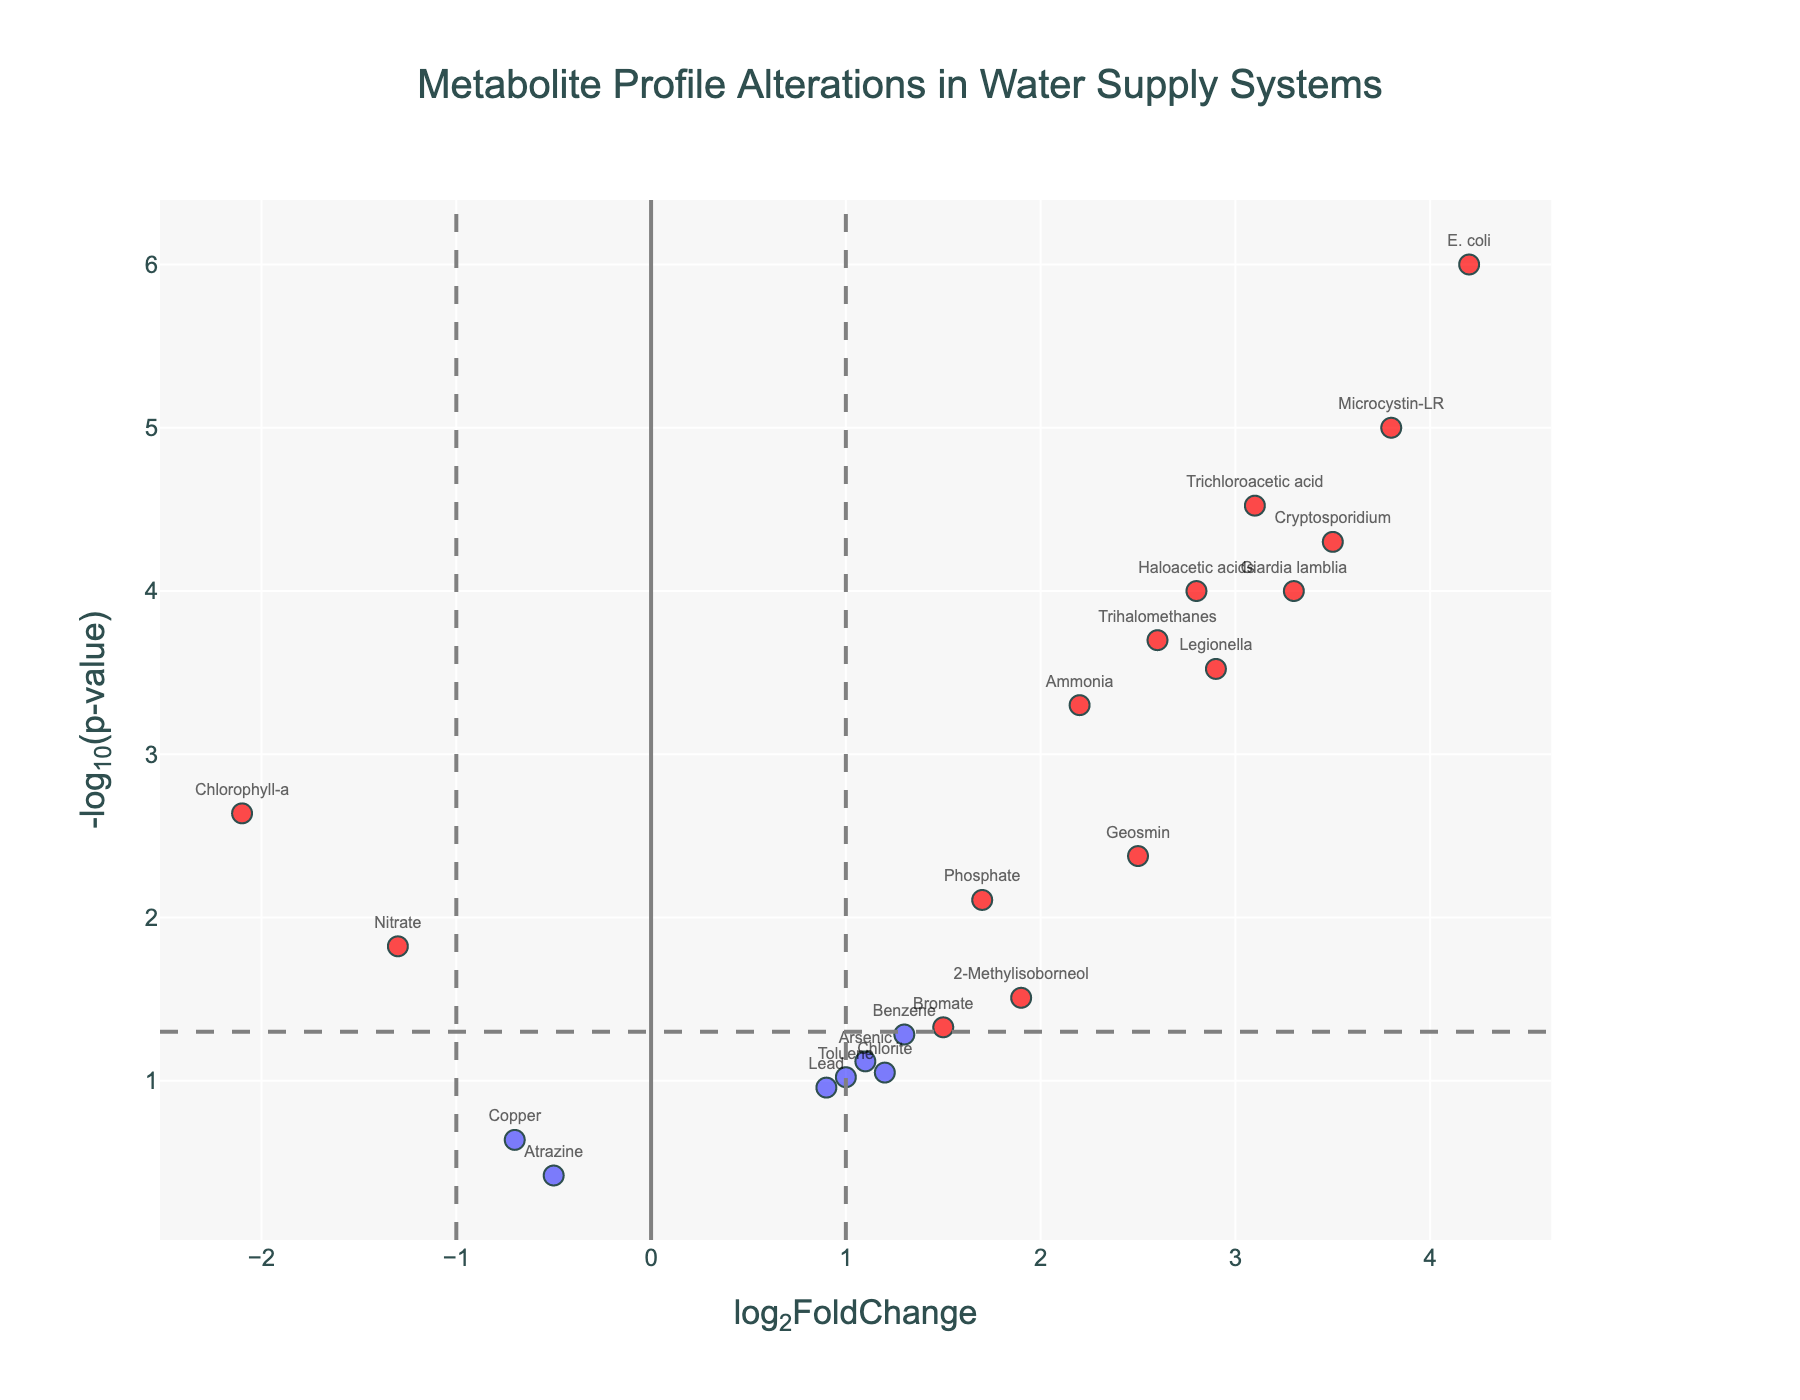What is the title of the plot? The title of the plot is positioned at the top center and reads "Metabolite Profile Alterations in Water Supply Systems."
Answer: Metabolite Profile Alterations in Water Supply Systems What do the x-axis and y-axis represent? The x-axis is labeled "log2FoldChange," indicating the log base 2 of the fold change of metabolites. The y-axis is labeled "-log10(p-value)," representing the negative logarithm base 10 of the p-value for each metabolite.
Answer: log2FoldChange (x-axis), -log10(p-value) (y-axis) How many metabolites have a log2 fold change greater than 1 and a p-value less than 0.05? Metabolites that meet these criteria are highlighted in red. By counting the red-highlighted points on the plot, there are 11 metabolites satisfying these conditions.
Answer: 11 Which metabolite shows the highest log2 fold change? By identifying the data point farthest to the right on the x-axis, E. coli has the highest log2 fold change of 4.2.
Answer: E. coli Which metabolite has the lowest p-value? The lowest p-value corresponds to the highest point on the y-axis. Microcystin-LR, with a -log10(p-value) becoming highest, has the lowest p-value of 0.00001.
Answer: Microcystin-LR How many metabolites have a p-value greater than 0.05? Metabolites with a p-value greater than 0.05 are those below the horizontal threshold line at -log10(0.05). Counting these points, there are 6 such metabolites.
Answer: 6 What is the log2 fold change and p-value for Nitrate? By examining the scatter labels, Nitrate is found to have a log2FoldChange of -1.3 and a p-value of 0.015 as per the provided data table.
Answer: log2FoldChange: -1.3, p-value: 0.015 Which metabolite shows the largest decrease in log2 fold change? The data point farthest to the left on the x-axis indicates the largest decrease. Chlorophyll-a has the lowest log2 fold change at -2.1.
Answer: Chlorophyll-a Do any metabolites have a log2 fold change between -1 and 1 and are considered significant (p-value < 0.05)? Significant metabolites have a -log10(p-value) above the horizontal threshold line. On the x-axis between -1 and 1, none of these metabolites have such a p-value.
Answer: No Between Legionella and Giardia lamblia, which has a higher log2 fold change? Both Legionella and Giardia lamblia are labeled on the plot. Comparing their x positions shows Legionella with a log2 fold change of 2.9, slightly higher than Giardia lamblia's 3.3.
Answer: Giardia lamblia 